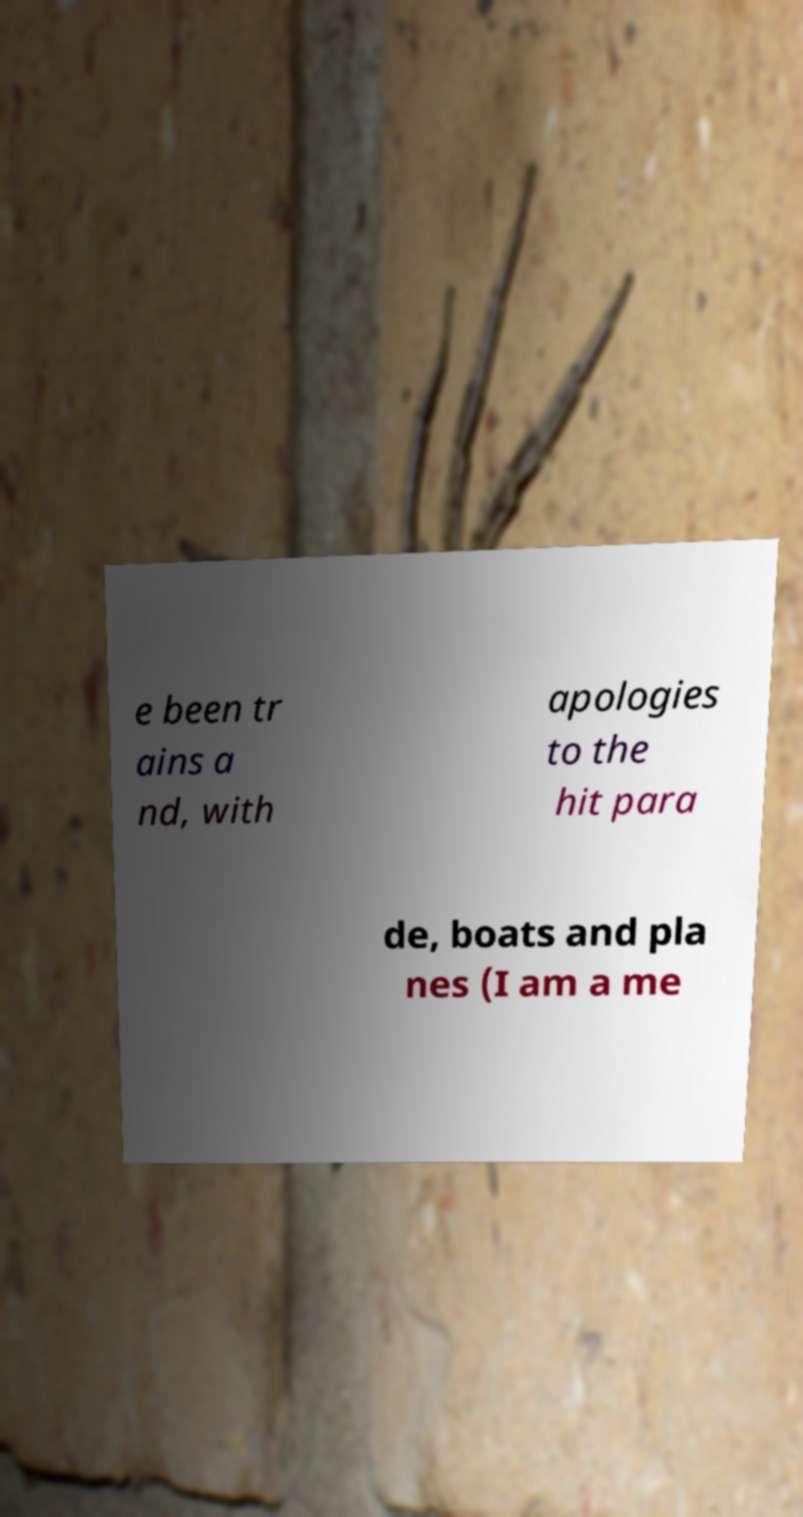Please read and relay the text visible in this image. What does it say? e been tr ains a nd, with apologies to the hit para de, boats and pla nes (I am a me 